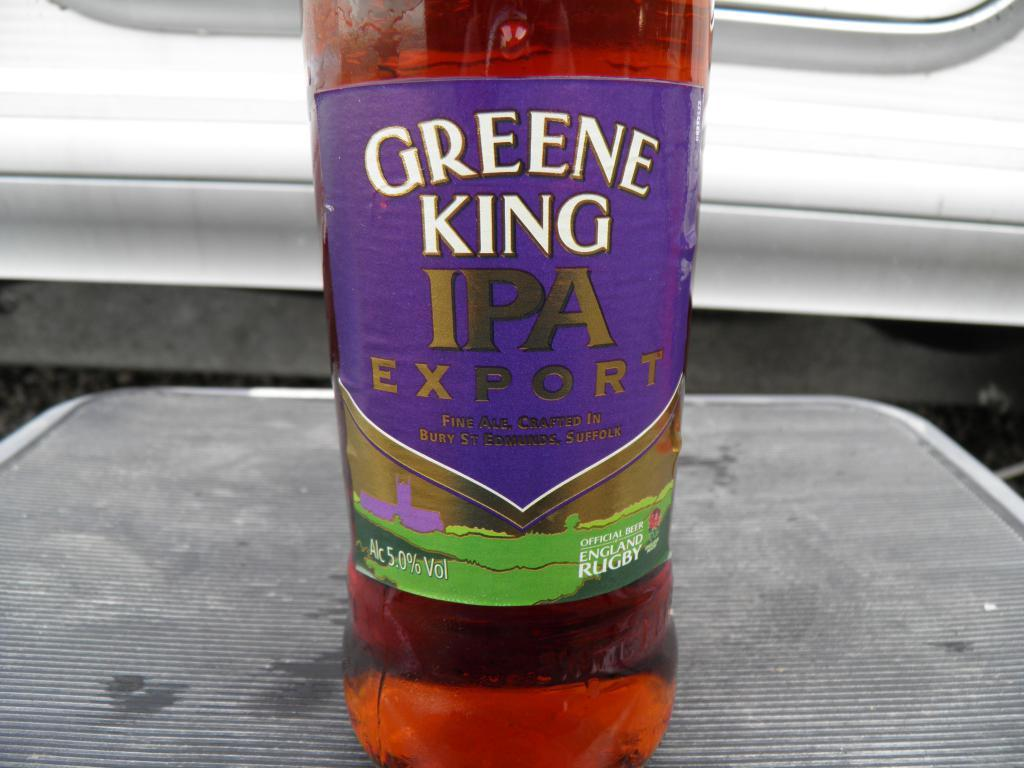<image>
Create a compact narrative representing the image presented. A bottle of Greene King IPA sits on a gray rubber mat. 